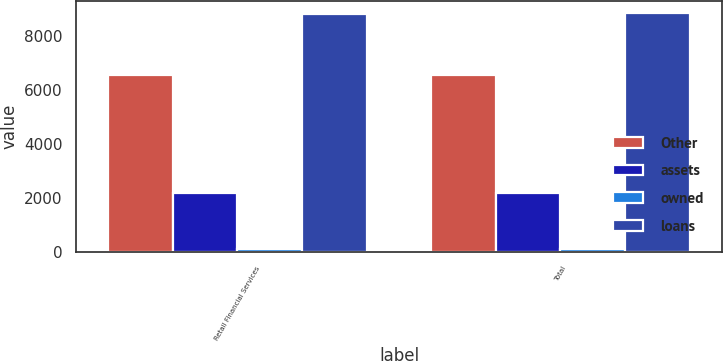Convert chart to OTSL. <chart><loc_0><loc_0><loc_500><loc_500><stacked_bar_chart><ecel><fcel>Retail Financial Services<fcel>Total<nl><fcel>Other<fcel>6548<fcel>6571<nl><fcel>assets<fcel>2183<fcel>2184<nl><fcel>owned<fcel>110<fcel>110<nl><fcel>loans<fcel>8841<fcel>8865<nl></chart> 